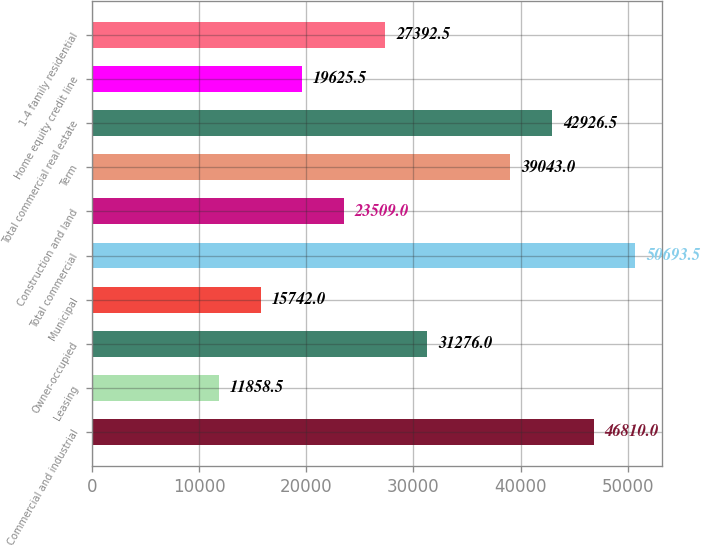<chart> <loc_0><loc_0><loc_500><loc_500><bar_chart><fcel>Commercial and industrial<fcel>Leasing<fcel>Owner-occupied<fcel>Municipal<fcel>Total commercial<fcel>Construction and land<fcel>Term<fcel>Total commercial real estate<fcel>Home equity credit line<fcel>1-4 family residential<nl><fcel>46810<fcel>11858.5<fcel>31276<fcel>15742<fcel>50693.5<fcel>23509<fcel>39043<fcel>42926.5<fcel>19625.5<fcel>27392.5<nl></chart> 